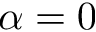Convert formula to latex. <formula><loc_0><loc_0><loc_500><loc_500>\alpha = 0</formula> 